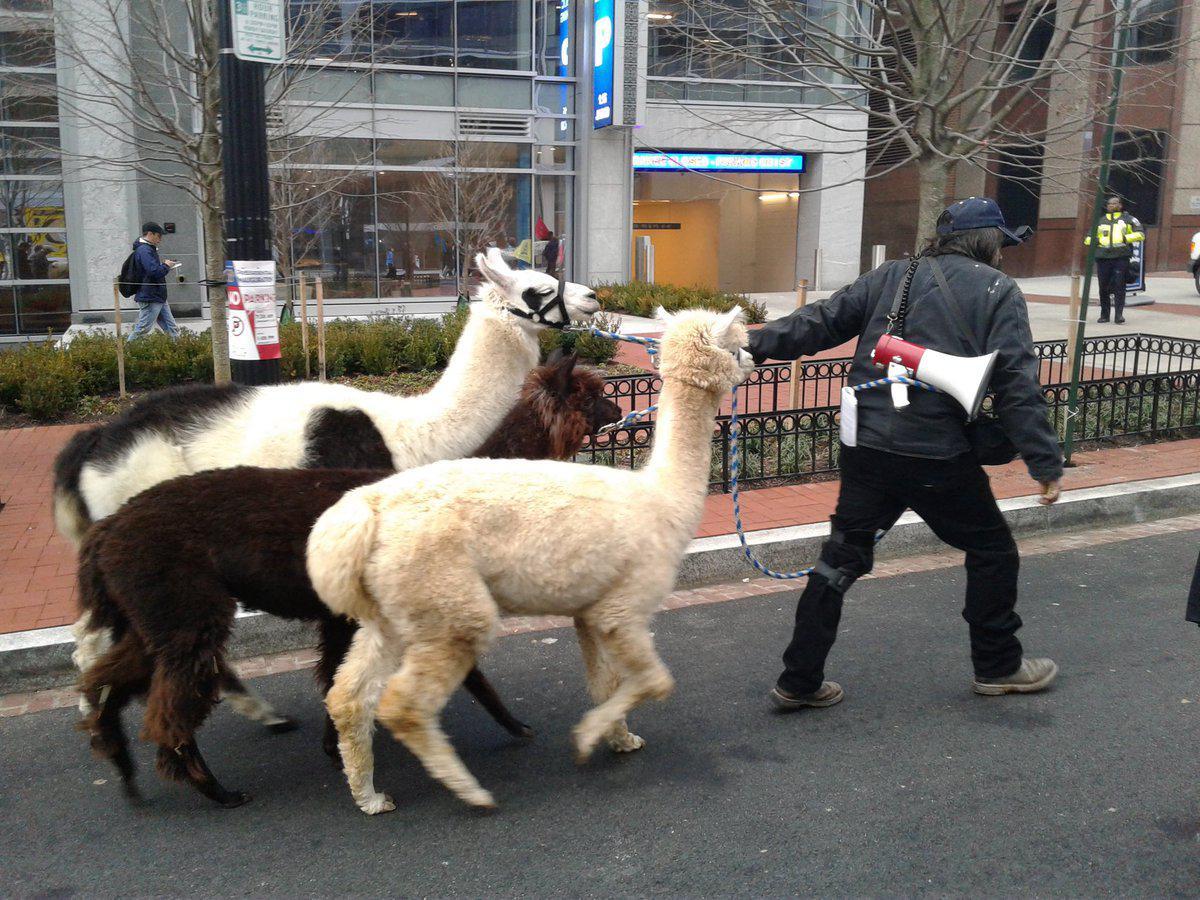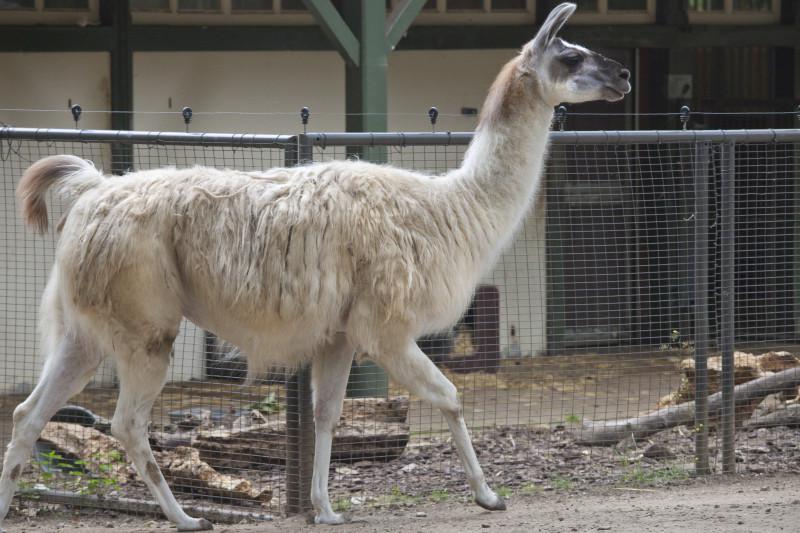The first image is the image on the left, the second image is the image on the right. Assess this claim about the two images: "All llama are standing with upright heads, and all llamas have their bodies turned rightward.". Correct or not? Answer yes or no. Yes. 